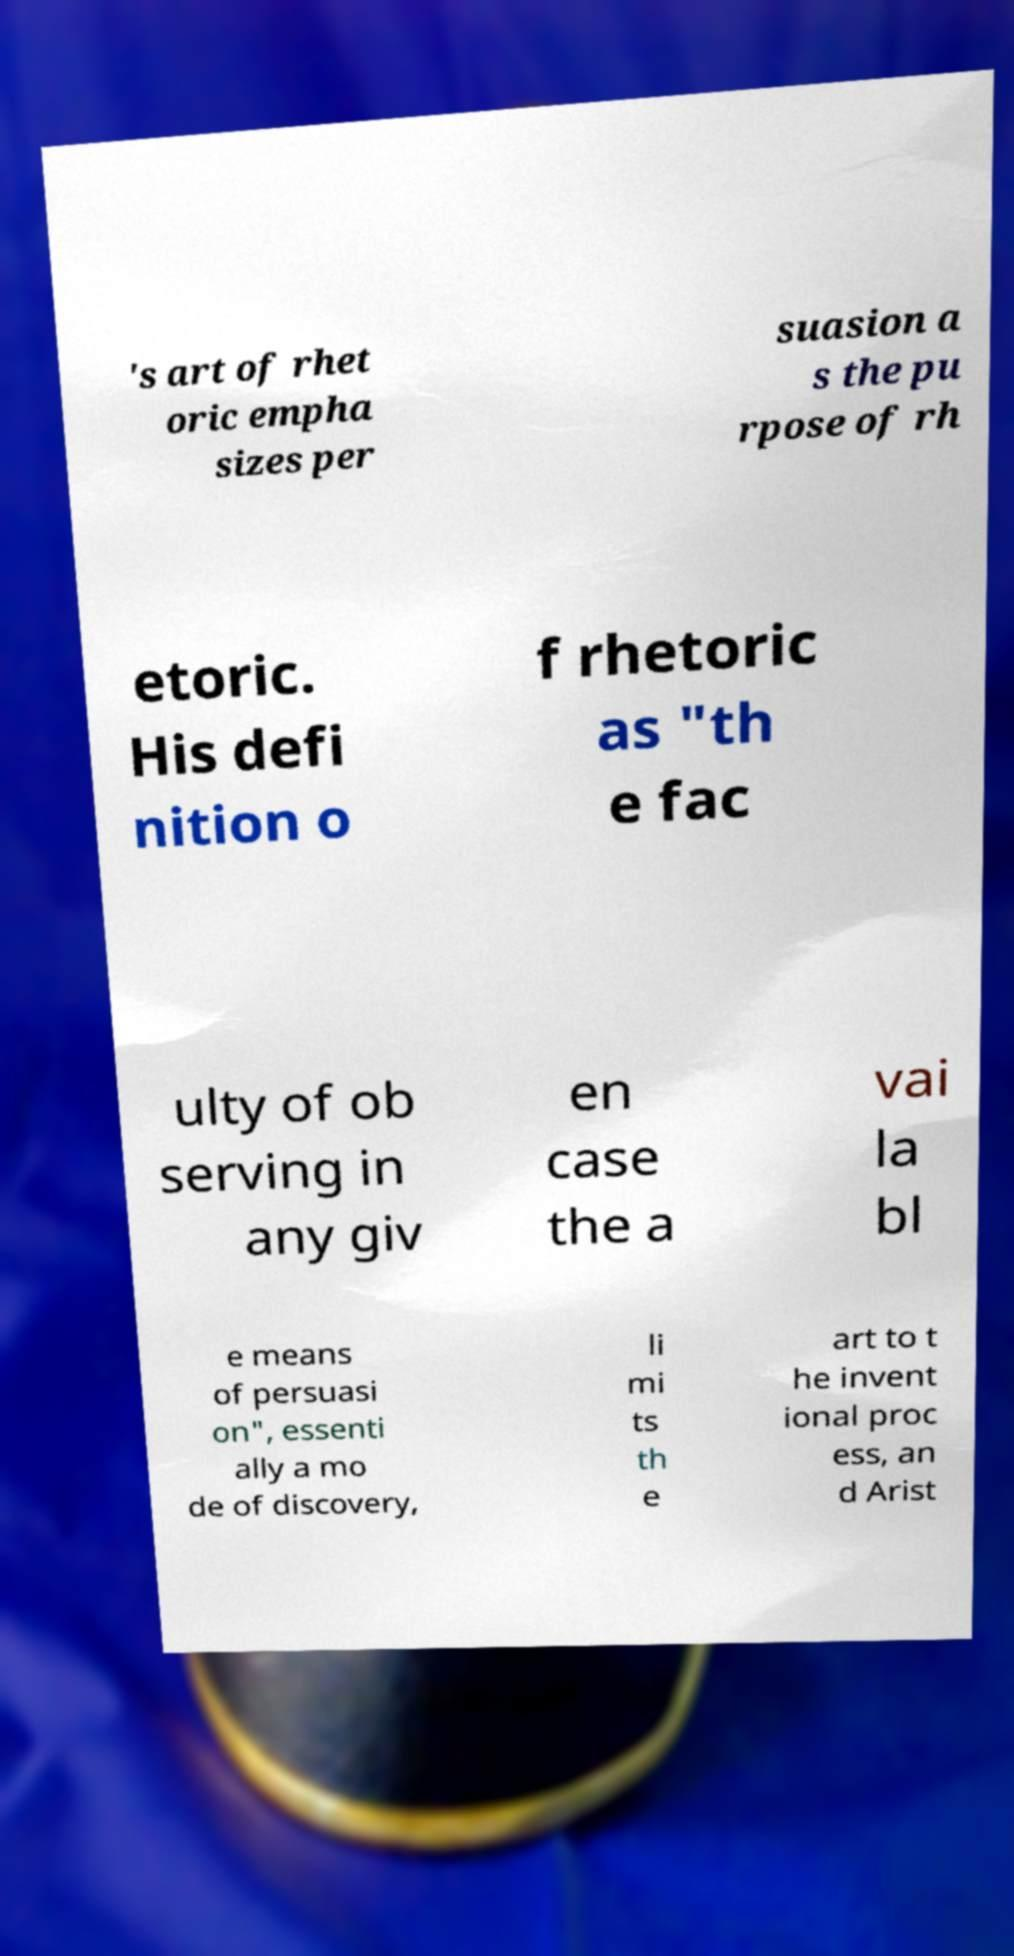Please read and relay the text visible in this image. What does it say? 's art of rhet oric empha sizes per suasion a s the pu rpose of rh etoric. His defi nition o f rhetoric as "th e fac ulty of ob serving in any giv en case the a vai la bl e means of persuasi on", essenti ally a mo de of discovery, li mi ts th e art to t he invent ional proc ess, an d Arist 